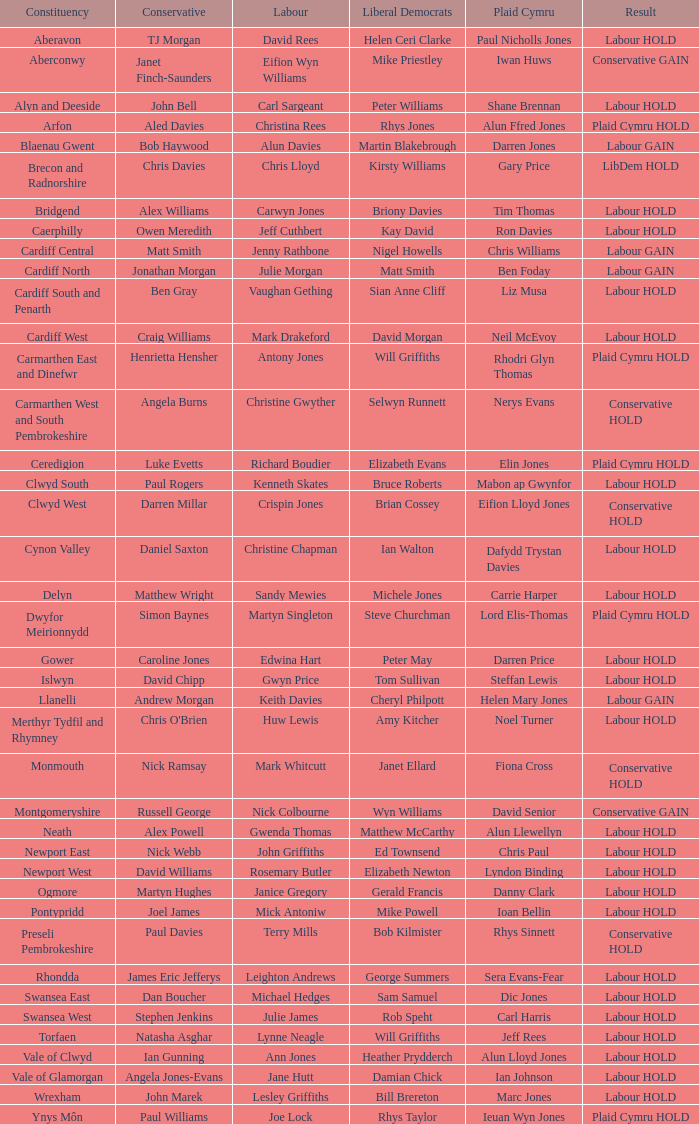What constituency does the Conservative Darren Millar belong to? Clwyd West. Help me parse the entirety of this table. {'header': ['Constituency', 'Conservative', 'Labour', 'Liberal Democrats', 'Plaid Cymru', 'Result'], 'rows': [['Aberavon', 'TJ Morgan', 'David Rees', 'Helen Ceri Clarke', 'Paul Nicholls Jones', 'Labour HOLD'], ['Aberconwy', 'Janet Finch-Saunders', 'Eifion Wyn Williams', 'Mike Priestley', 'Iwan Huws', 'Conservative GAIN'], ['Alyn and Deeside', 'John Bell', 'Carl Sargeant', 'Peter Williams', 'Shane Brennan', 'Labour HOLD'], ['Arfon', 'Aled Davies', 'Christina Rees', 'Rhys Jones', 'Alun Ffred Jones', 'Plaid Cymru HOLD'], ['Blaenau Gwent', 'Bob Haywood', 'Alun Davies', 'Martin Blakebrough', 'Darren Jones', 'Labour GAIN'], ['Brecon and Radnorshire', 'Chris Davies', 'Chris Lloyd', 'Kirsty Williams', 'Gary Price', 'LibDem HOLD'], ['Bridgend', 'Alex Williams', 'Carwyn Jones', 'Briony Davies', 'Tim Thomas', 'Labour HOLD'], ['Caerphilly', 'Owen Meredith', 'Jeff Cuthbert', 'Kay David', 'Ron Davies', 'Labour HOLD'], ['Cardiff Central', 'Matt Smith', 'Jenny Rathbone', 'Nigel Howells', 'Chris Williams', 'Labour GAIN'], ['Cardiff North', 'Jonathan Morgan', 'Julie Morgan', 'Matt Smith', 'Ben Foday', 'Labour GAIN'], ['Cardiff South and Penarth', 'Ben Gray', 'Vaughan Gething', 'Sian Anne Cliff', 'Liz Musa', 'Labour HOLD'], ['Cardiff West', 'Craig Williams', 'Mark Drakeford', 'David Morgan', 'Neil McEvoy', 'Labour HOLD'], ['Carmarthen East and Dinefwr', 'Henrietta Hensher', 'Antony Jones', 'Will Griffiths', 'Rhodri Glyn Thomas', 'Plaid Cymru HOLD'], ['Carmarthen West and South Pembrokeshire', 'Angela Burns', 'Christine Gwyther', 'Selwyn Runnett', 'Nerys Evans', 'Conservative HOLD'], ['Ceredigion', 'Luke Evetts', 'Richard Boudier', 'Elizabeth Evans', 'Elin Jones', 'Plaid Cymru HOLD'], ['Clwyd South', 'Paul Rogers', 'Kenneth Skates', 'Bruce Roberts', 'Mabon ap Gwynfor', 'Labour HOLD'], ['Clwyd West', 'Darren Millar', 'Crispin Jones', 'Brian Cossey', 'Eifion Lloyd Jones', 'Conservative HOLD'], ['Cynon Valley', 'Daniel Saxton', 'Christine Chapman', 'Ian Walton', 'Dafydd Trystan Davies', 'Labour HOLD'], ['Delyn', 'Matthew Wright', 'Sandy Mewies', 'Michele Jones', 'Carrie Harper', 'Labour HOLD'], ['Dwyfor Meirionnydd', 'Simon Baynes', 'Martyn Singleton', 'Steve Churchman', 'Lord Elis-Thomas', 'Plaid Cymru HOLD'], ['Gower', 'Caroline Jones', 'Edwina Hart', 'Peter May', 'Darren Price', 'Labour HOLD'], ['Islwyn', 'David Chipp', 'Gwyn Price', 'Tom Sullivan', 'Steffan Lewis', 'Labour HOLD'], ['Llanelli', 'Andrew Morgan', 'Keith Davies', 'Cheryl Philpott', 'Helen Mary Jones', 'Labour GAIN'], ['Merthyr Tydfil and Rhymney', "Chris O'Brien", 'Huw Lewis', 'Amy Kitcher', 'Noel Turner', 'Labour HOLD'], ['Monmouth', 'Nick Ramsay', 'Mark Whitcutt', 'Janet Ellard', 'Fiona Cross', 'Conservative HOLD'], ['Montgomeryshire', 'Russell George', 'Nick Colbourne', 'Wyn Williams', 'David Senior', 'Conservative GAIN'], ['Neath', 'Alex Powell', 'Gwenda Thomas', 'Matthew McCarthy', 'Alun Llewellyn', 'Labour HOLD'], ['Newport East', 'Nick Webb', 'John Griffiths', 'Ed Townsend', 'Chris Paul', 'Labour HOLD'], ['Newport West', 'David Williams', 'Rosemary Butler', 'Elizabeth Newton', 'Lyndon Binding', 'Labour HOLD'], ['Ogmore', 'Martyn Hughes', 'Janice Gregory', 'Gerald Francis', 'Danny Clark', 'Labour HOLD'], ['Pontypridd', 'Joel James', 'Mick Antoniw', 'Mike Powell', 'Ioan Bellin', 'Labour HOLD'], ['Preseli Pembrokeshire', 'Paul Davies', 'Terry Mills', 'Bob Kilmister', 'Rhys Sinnett', 'Conservative HOLD'], ['Rhondda', 'James Eric Jefferys', 'Leighton Andrews', 'George Summers', 'Sera Evans-Fear', 'Labour HOLD'], ['Swansea East', 'Dan Boucher', 'Michael Hedges', 'Sam Samuel', 'Dic Jones', 'Labour HOLD'], ['Swansea West', 'Stephen Jenkins', 'Julie James', 'Rob Speht', 'Carl Harris', 'Labour HOLD'], ['Torfaen', 'Natasha Asghar', 'Lynne Neagle', 'Will Griffiths', 'Jeff Rees', 'Labour HOLD'], ['Vale of Clwyd', 'Ian Gunning', 'Ann Jones', 'Heather Prydderch', 'Alun Lloyd Jones', 'Labour HOLD'], ['Vale of Glamorgan', 'Angela Jones-Evans', 'Jane Hutt', 'Damian Chick', 'Ian Johnson', 'Labour HOLD'], ['Wrexham', 'John Marek', 'Lesley Griffiths', 'Bill Brereton', 'Marc Jones', 'Labour HOLD'], ['Ynys Môn', 'Paul Williams', 'Joe Lock', 'Rhys Taylor', 'Ieuan Wyn Jones', 'Plaid Cymru HOLD']]} 